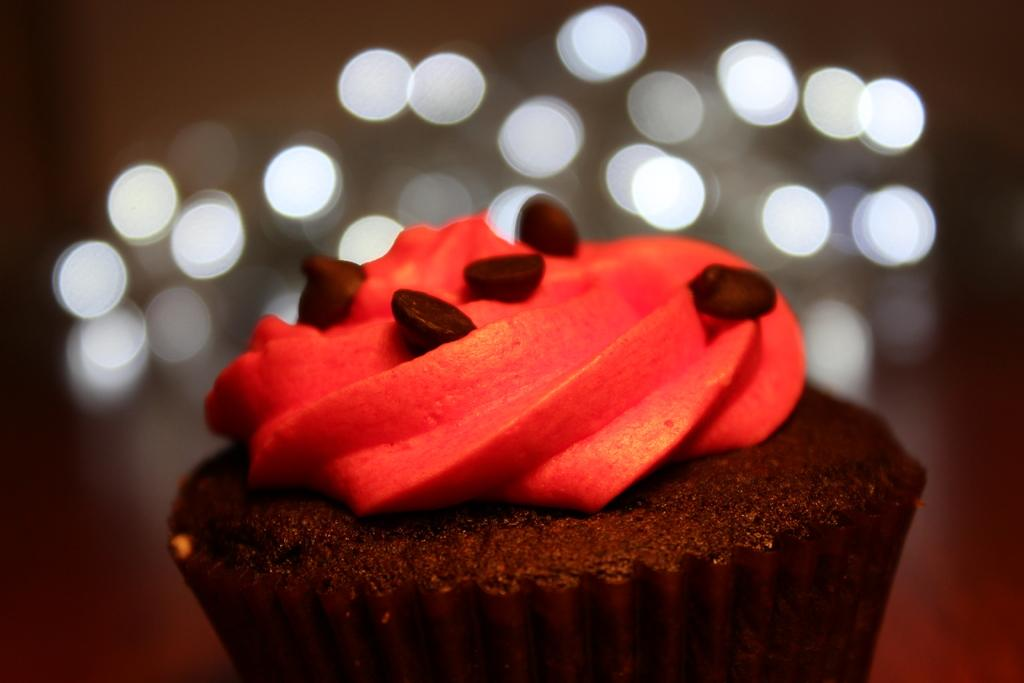What type of dessert is visible in the image? There is a cupcake in the image. What can be seen in the background of the image? There are lights in the background of the image. What is the angle of the slope in the image? There is no slope present in the image. How many times does the light cry in the image? There is no crying light in the image; the lights are stationary and do not have emotions. 